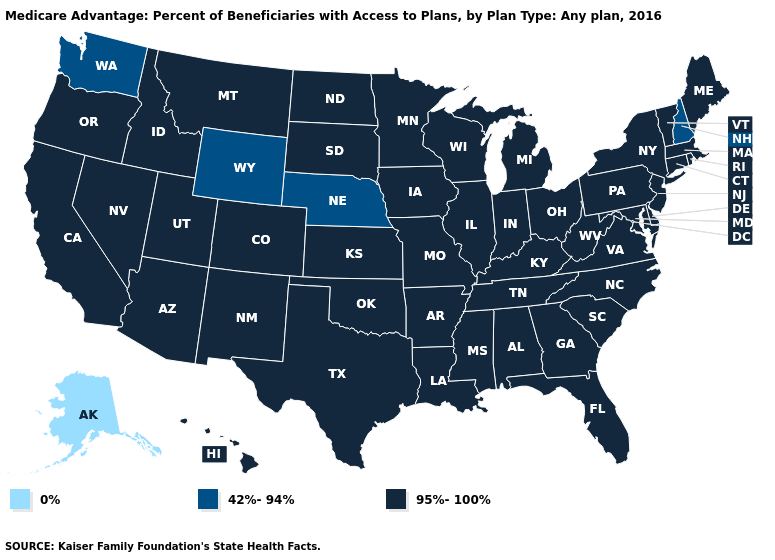How many symbols are there in the legend?
Short answer required. 3. Name the states that have a value in the range 42%-94%?
Give a very brief answer. Nebraska, New Hampshire, Washington, Wyoming. What is the value of Alaska?
Give a very brief answer. 0%. Does Alaska have the highest value in the West?
Write a very short answer. No. Does Idaho have the same value as Alaska?
Give a very brief answer. No. What is the value of Oklahoma?
Write a very short answer. 95%-100%. What is the value of Missouri?
Answer briefly. 95%-100%. Does Minnesota have the highest value in the USA?
Be succinct. Yes. Does Alaska have the lowest value in the USA?
Write a very short answer. Yes. Name the states that have a value in the range 42%-94%?
Write a very short answer. Nebraska, New Hampshire, Washington, Wyoming. What is the value of New Hampshire?
Keep it brief. 42%-94%. Does New Hampshire have the highest value in the USA?
Short answer required. No. Does the map have missing data?
Give a very brief answer. No. Among the states that border Arkansas , which have the lowest value?
Give a very brief answer. Louisiana, Missouri, Mississippi, Oklahoma, Tennessee, Texas. 